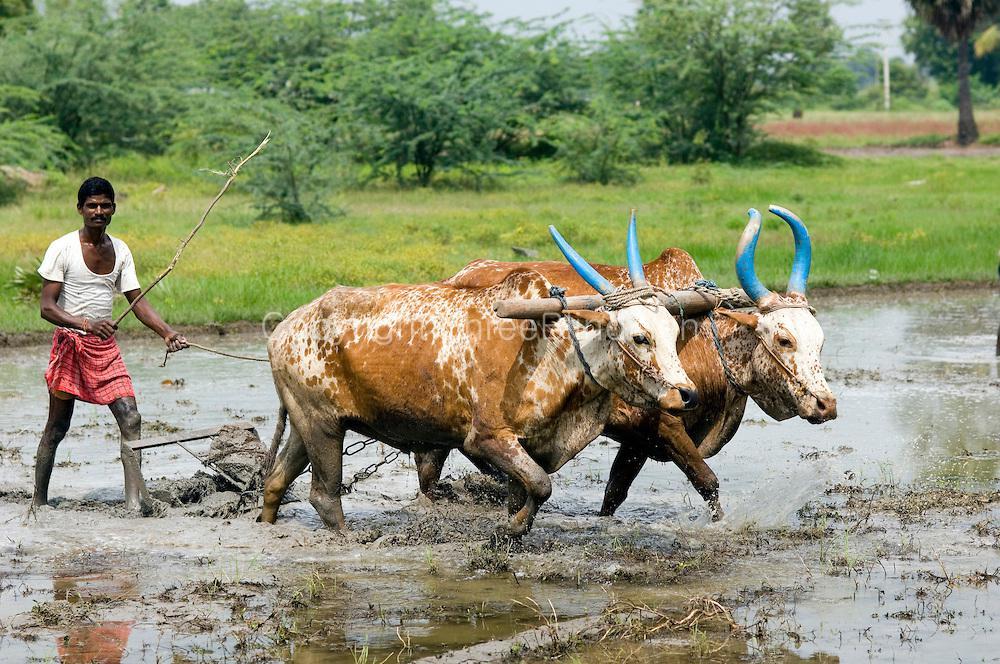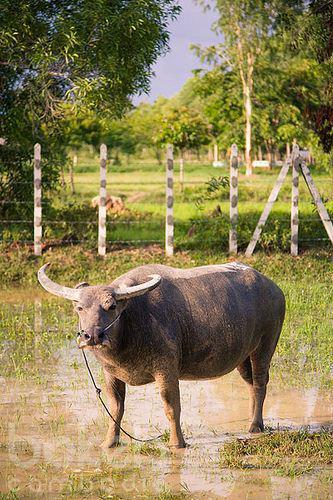The first image is the image on the left, the second image is the image on the right. Given the left and right images, does the statement "An image shows a man wielding a stick behind a plow pulled by two cattle." hold true? Answer yes or no. Yes. The first image is the image on the left, the second image is the image on the right. Evaluate the accuracy of this statement regarding the images: "In one image, a farmer is guiding a plow that two animals with horns are pulling through a watery field.". Is it true? Answer yes or no. Yes. 